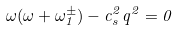Convert formula to latex. <formula><loc_0><loc_0><loc_500><loc_500>\omega ( \omega + \omega ^ { \pm } _ { 1 } ) - c _ { s } ^ { 2 } q ^ { 2 } = 0</formula> 